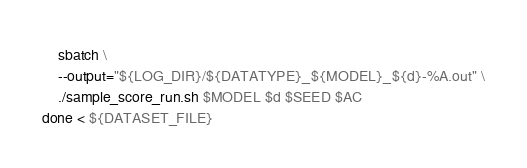<code> <loc_0><loc_0><loc_500><loc_500><_Bash_>    sbatch \
    --output="${LOG_DIR}/${DATATYPE}_${MODEL}_${d}-%A.out" \
    ./sample_score_run.sh $MODEL $d $SEED $AC
done < ${DATASET_FILE}
</code> 